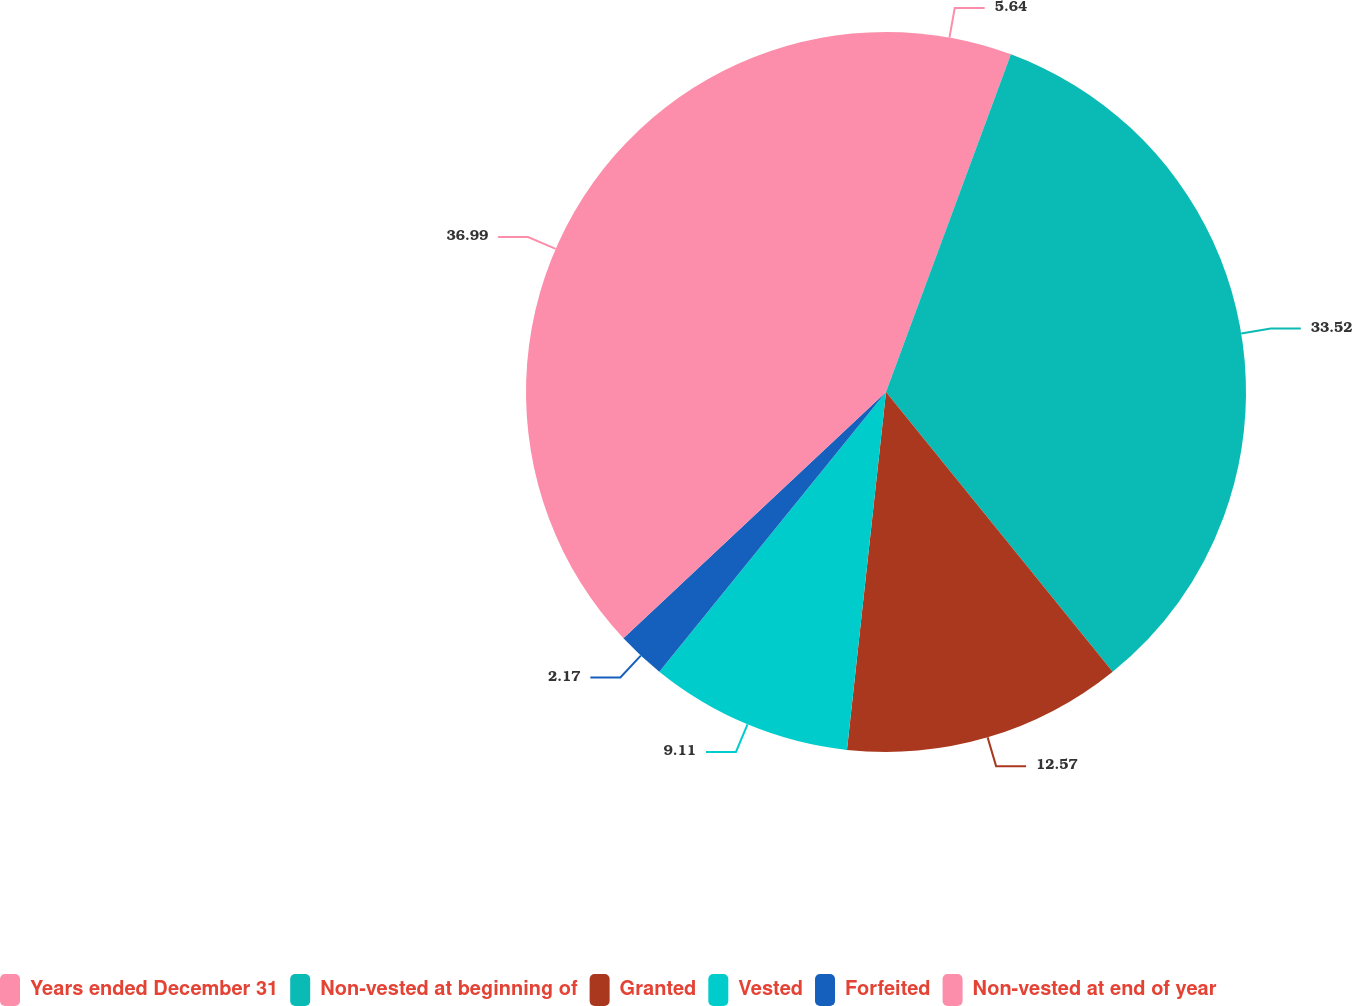<chart> <loc_0><loc_0><loc_500><loc_500><pie_chart><fcel>Years ended December 31<fcel>Non-vested at beginning of<fcel>Granted<fcel>Vested<fcel>Forfeited<fcel>Non-vested at end of year<nl><fcel>5.64%<fcel>33.52%<fcel>12.57%<fcel>9.11%<fcel>2.17%<fcel>36.99%<nl></chart> 